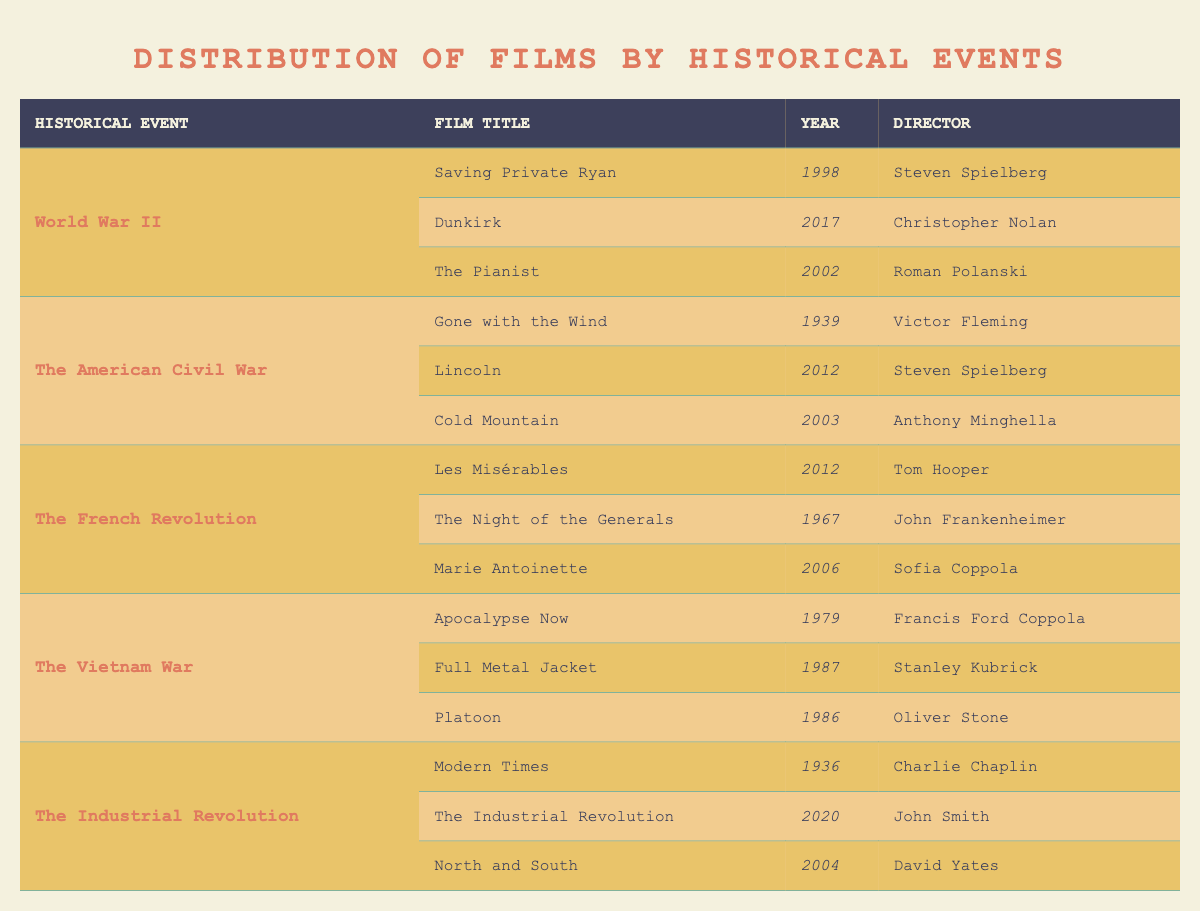What films depict World War II? The table lists three films under the 'World War II' event: "Saving Private Ryan," "Dunkirk," and "The Pianist."
Answer: Saving Private Ryan, Dunkirk, The Pianist Which director made the film "Lincoln"? The table shows that "Lincoln" was directed by Steven Spielberg.
Answer: Steven Spielberg How many films are listed for The American Civil War? The table displays three films associated with The American Civil War: "Gone with the Wind," "Lincoln," and "Cold Mountain." Thus, the count is 3.
Answer: 3 Which film has the earliest release date among those depicting the Vietnam War? The films under the Vietnam War are: "Apocalypse Now" (1979), "Full Metal Jacket" (1987), and "Platoon" (1986). "Apocalypse Now," released in 1979, is the earliest.
Answer: Apocalypse Now Is "Les Misérables" directed by Sofia Coppola? The entry for "Les Misérables" in the table indicates that it was directed by Tom Hooper, not Sofia Coppola. Therefore, the statement is false.
Answer: No How many films are directed by Steven Spielberg among those listed in the table? Steven Spielberg directed two films: "Saving Private Ryan" under World War II and "Lincoln" under The American Civil War. Adding them gives a total of 2.
Answer: 2 What is the most recent film listed about the Industrial Revolution? According to the table, "The Industrial Revolution," released in 2020, is the only film in that category and is therefore the most recent.
Answer: The Industrial Revolution Which director has made films about both the American Civil War and World War II? The table shows Steven Spielberg directed "Lincoln" (American Civil War) and "Saving Private Ryan" (World War II). Hence, he qualifies as the director for both events.
Answer: Steven Spielberg Which film depicts The French Revolution and was released earliest? The films under The French Revolution include "Les Misérables" (2012), "The Night of the Generals" (1967), and "Marie Antoinette" (2006). Comparing the years, "The Night of the Generals" is the earliest released in 1967.
Answer: The Night of the Generals 